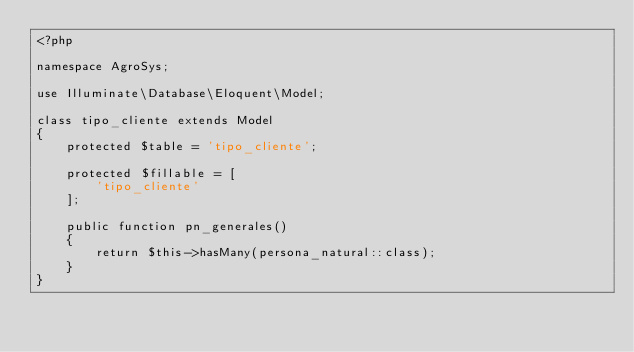Convert code to text. <code><loc_0><loc_0><loc_500><loc_500><_PHP_><?php

namespace AgroSys;

use Illuminate\Database\Eloquent\Model;

class tipo_cliente extends Model
{
    protected $table = 'tipo_cliente';

    protected $fillable = [
    		'tipo_cliente'    		
    ];

    public function pn_generales()
    {
        return $this->hasMany(persona_natural::class);
    }
}
</code> 